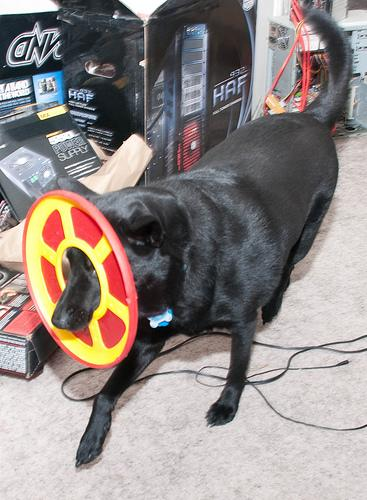Mention any text or words visible in the image. The word "supply" is visible on a box. In a poetic manner, describe the interaction between the dog and the frisbee. Amidst chaotic wires and boxes, a black canine elegantly strides with a halo of red and yellow, a frisbee gently rests upon its noble head. Identify the primary color and object resting on the dog's head in the image. The primary color is black, and there's a red and yellow frisbee on the dog's head. What is the activity happening in the scene including the main subject and surrounding elements? A black dog with a red and yellow frisbee on its head is walking through an environment filled with computer equipment, boxes, and wires. Describe the appearance and color of the dog's collar and its tag. The dog's collar is blue and white, and its tag is blue. Enumerate three objects found on the floor in the image. A black electrical wire, a box on the floor, and an orange electrical extension cord. What emotions or sentiments could be evoked by the image of the dog and its surroundings? The image could evoke amusement, curiosity, and maybe a touch of chaos or disorganization. Explain the distinguishing feature of the frisbee on the dog's head. The frisbee is round and has a unique yellow and red color combination with a hole in the center. In the context of the image, define the relationship between the dog and the computer equipment. The dog is in the midst of the computer equipment, seemingly unbothered or curious about its surroundings. Count the number of legs of the dog that are visible in the image and briefly describe their position. Four legs of the dog are visible: the front left and right legs and the back left and right legs. 